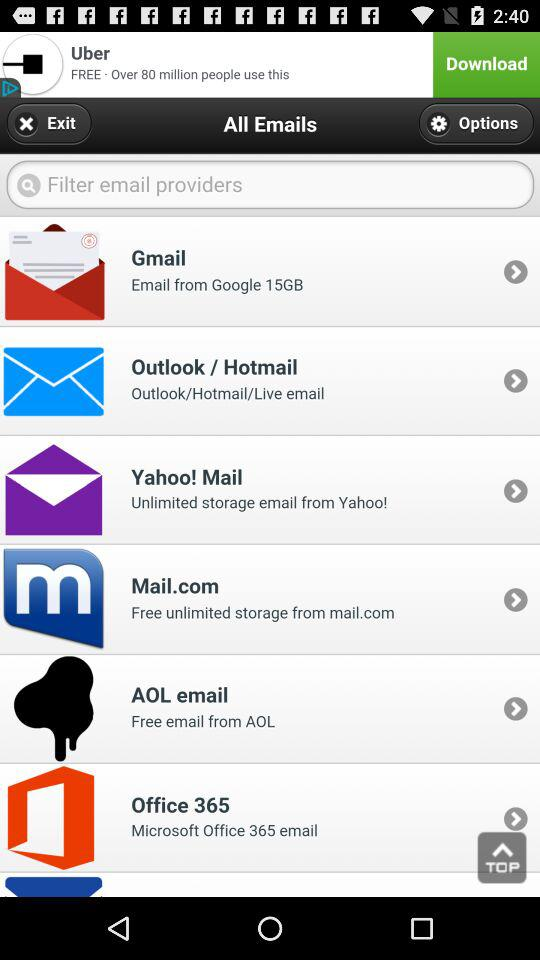How much does AOL email cost for emails?
When the provided information is insufficient, respond with <no answer>. <no answer> 